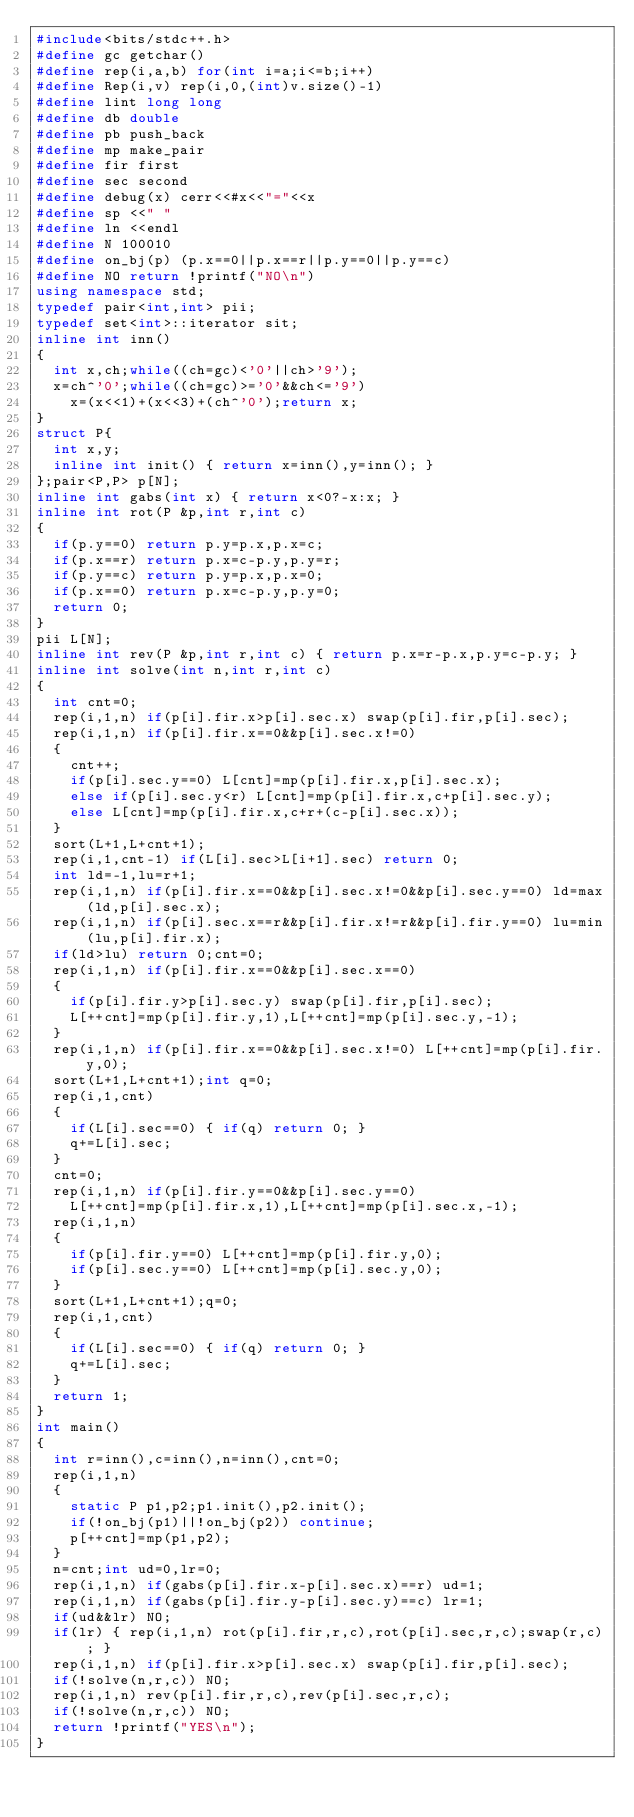<code> <loc_0><loc_0><loc_500><loc_500><_C++_>#include<bits/stdc++.h>
#define gc getchar()
#define rep(i,a,b) for(int i=a;i<=b;i++)
#define Rep(i,v) rep(i,0,(int)v.size()-1)
#define lint long long
#define db double
#define pb push_back
#define mp make_pair
#define fir first
#define sec second
#define debug(x) cerr<<#x<<"="<<x
#define sp <<" "
#define ln <<endl
#define N 100010
#define on_bj(p) (p.x==0||p.x==r||p.y==0||p.y==c)
#define NO return !printf("NO\n")
using namespace std;
typedef pair<int,int> pii;
typedef set<int>::iterator sit;
inline int inn()
{
	int x,ch;while((ch=gc)<'0'||ch>'9');
	x=ch^'0';while((ch=gc)>='0'&&ch<='9')
		x=(x<<1)+(x<<3)+(ch^'0');return x;
}
struct P{
	int x,y;
	inline int init() { return x=inn(),y=inn(); }
};pair<P,P> p[N];
inline int gabs(int x) { return x<0?-x:x; }
inline int rot(P &p,int r,int c)
{
	if(p.y==0) return p.y=p.x,p.x=c;
	if(p.x==r) return p.x=c-p.y,p.y=r;
	if(p.y==c) return p.y=p.x,p.x=0;
	if(p.x==0) return p.x=c-p.y,p.y=0;
	return 0;
}
pii L[N];
inline int rev(P &p,int r,int c) { return p.x=r-p.x,p.y=c-p.y; }
inline int solve(int n,int r,int c)
{
	int cnt=0;
	rep(i,1,n) if(p[i].fir.x>p[i].sec.x) swap(p[i].fir,p[i].sec);
	rep(i,1,n) if(p[i].fir.x==0&&p[i].sec.x!=0)
	{
		cnt++;
		if(p[i].sec.y==0) L[cnt]=mp(p[i].fir.x,p[i].sec.x);
		else if(p[i].sec.y<r) L[cnt]=mp(p[i].fir.x,c+p[i].sec.y);
		else L[cnt]=mp(p[i].fir.x,c+r+(c-p[i].sec.x));
	}
	sort(L+1,L+cnt+1);
	rep(i,1,cnt-1) if(L[i].sec>L[i+1].sec) return 0;
	int ld=-1,lu=r+1;
	rep(i,1,n) if(p[i].fir.x==0&&p[i].sec.x!=0&&p[i].sec.y==0) ld=max(ld,p[i].sec.x);
	rep(i,1,n) if(p[i].sec.x==r&&p[i].fir.x!=r&&p[i].fir.y==0) lu=min(lu,p[i].fir.x);
	if(ld>lu) return 0;cnt=0;
	rep(i,1,n) if(p[i].fir.x==0&&p[i].sec.x==0)
	{
		if(p[i].fir.y>p[i].sec.y) swap(p[i].fir,p[i].sec);
		L[++cnt]=mp(p[i].fir.y,1),L[++cnt]=mp(p[i].sec.y,-1);
	}
	rep(i,1,n) if(p[i].fir.x==0&&p[i].sec.x!=0) L[++cnt]=mp(p[i].fir.y,0);
	sort(L+1,L+cnt+1);int q=0;
	rep(i,1,cnt)
	{
		if(L[i].sec==0) { if(q) return 0; }
		q+=L[i].sec;
	}
	cnt=0;
	rep(i,1,n) if(p[i].fir.y==0&&p[i].sec.y==0)
		L[++cnt]=mp(p[i].fir.x,1),L[++cnt]=mp(p[i].sec.x,-1);
	rep(i,1,n)
	{
		if(p[i].fir.y==0) L[++cnt]=mp(p[i].fir.y,0);
		if(p[i].sec.y==0) L[++cnt]=mp(p[i].sec.y,0);
	}
	sort(L+1,L+cnt+1);q=0;
	rep(i,1,cnt)
	{
		if(L[i].sec==0) { if(q) return 0; }
		q+=L[i].sec;
	}
	return 1;
}
int main()
{
	int r=inn(),c=inn(),n=inn(),cnt=0;
	rep(i,1,n)
	{
		static P p1,p2;p1.init(),p2.init();
		if(!on_bj(p1)||!on_bj(p2)) continue;
		p[++cnt]=mp(p1,p2);
	}
	n=cnt;int ud=0,lr=0;
	rep(i,1,n) if(gabs(p[i].fir.x-p[i].sec.x)==r) ud=1;
	rep(i,1,n) if(gabs(p[i].fir.y-p[i].sec.y)==c) lr=1;
	if(ud&&lr) NO;
	if(lr) { rep(i,1,n) rot(p[i].fir,r,c),rot(p[i].sec,r,c);swap(r,c); }
	rep(i,1,n) if(p[i].fir.x>p[i].sec.x) swap(p[i].fir,p[i].sec);
	if(!solve(n,r,c)) NO;
	rep(i,1,n) rev(p[i].fir,r,c),rev(p[i].sec,r,c);
	if(!solve(n,r,c)) NO;
	return !printf("YES\n");
}</code> 